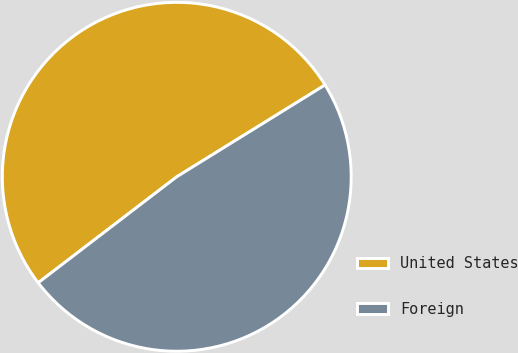<chart> <loc_0><loc_0><loc_500><loc_500><pie_chart><fcel>United States<fcel>Foreign<nl><fcel>51.57%<fcel>48.43%<nl></chart> 